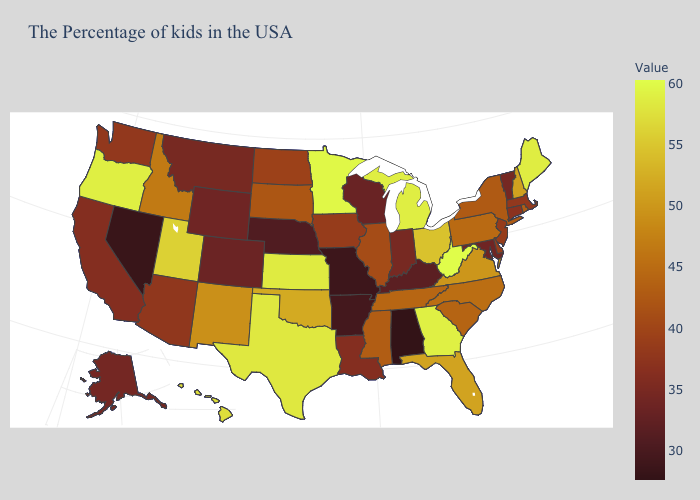Does Idaho have a lower value than Florida?
Keep it brief. Yes. Among the states that border Michigan , does Ohio have the highest value?
Quick response, please. Yes. Is the legend a continuous bar?
Write a very short answer. Yes. Among the states that border Pennsylvania , does Delaware have the lowest value?
Be succinct. No. Among the states that border New Hampshire , which have the highest value?
Give a very brief answer. Maine. 